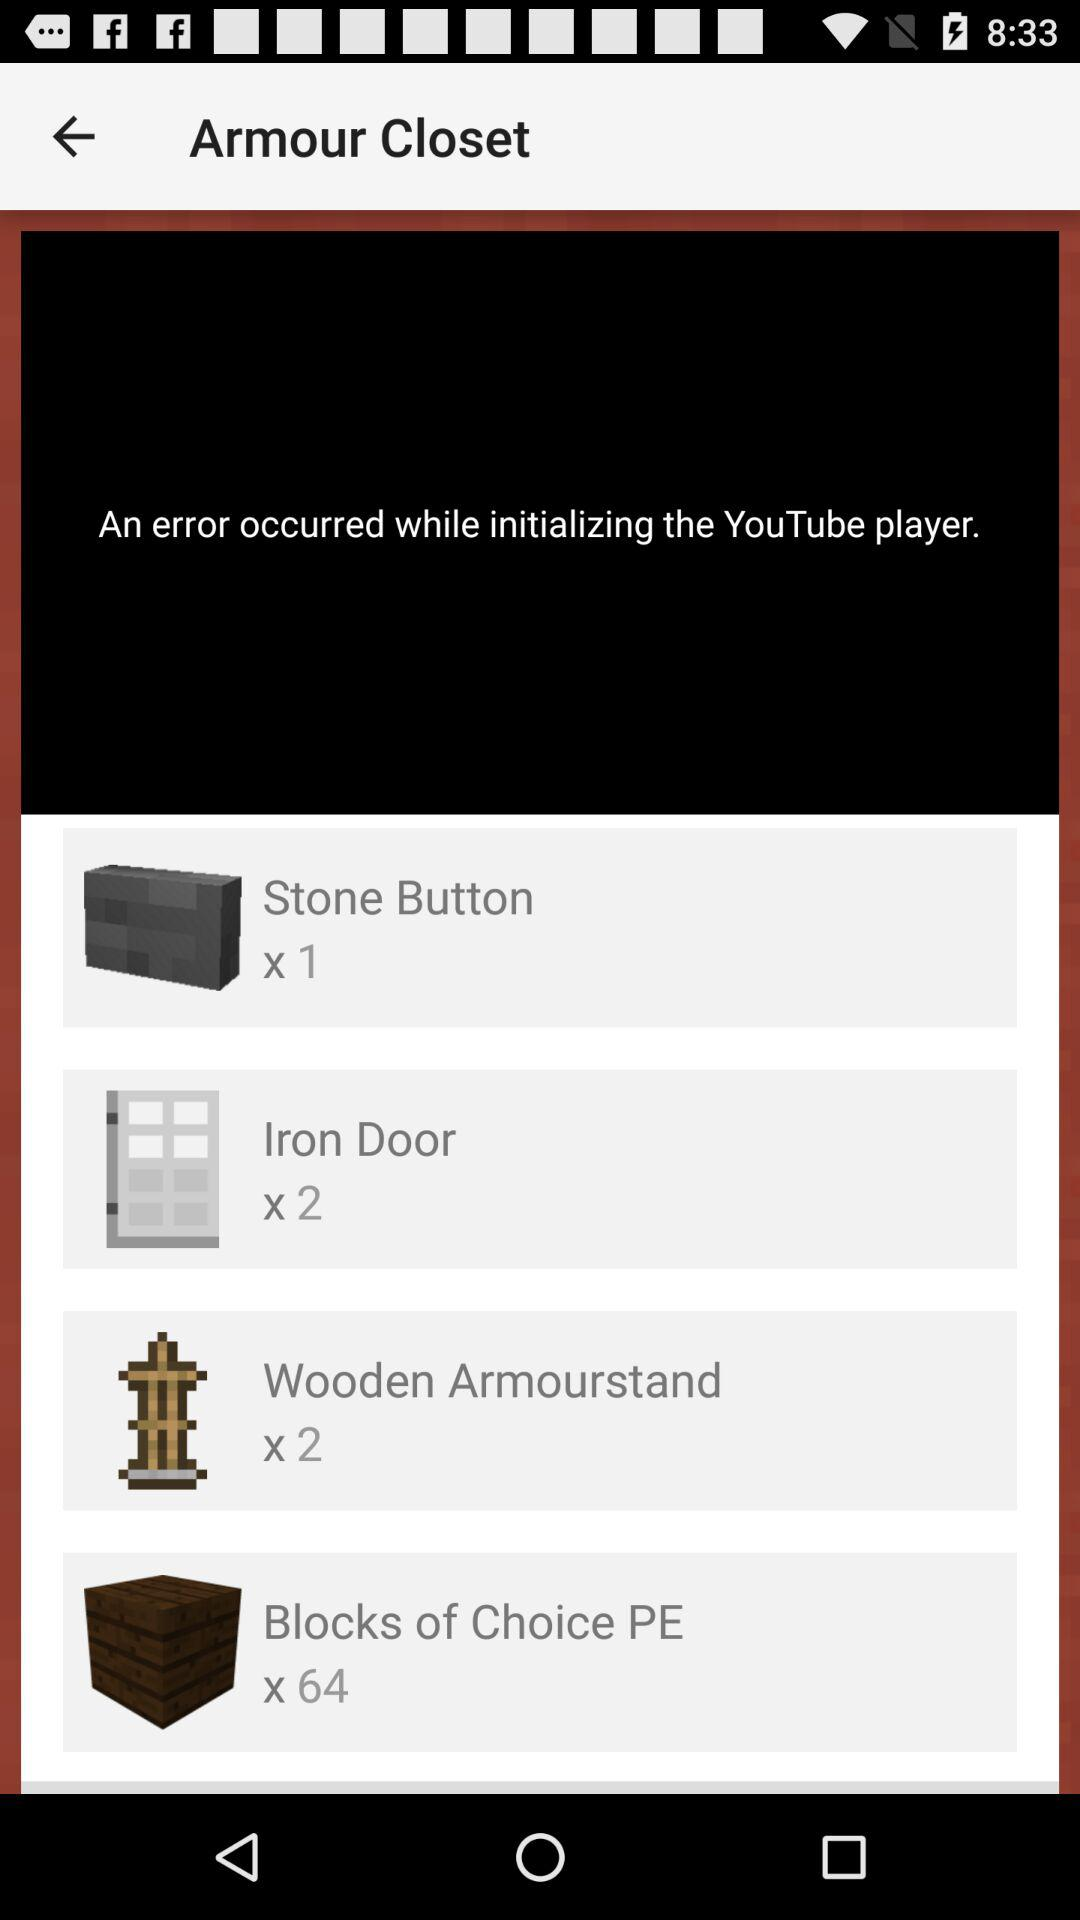How many wooden armourstands are there? There are 2 wooden armourstands. 